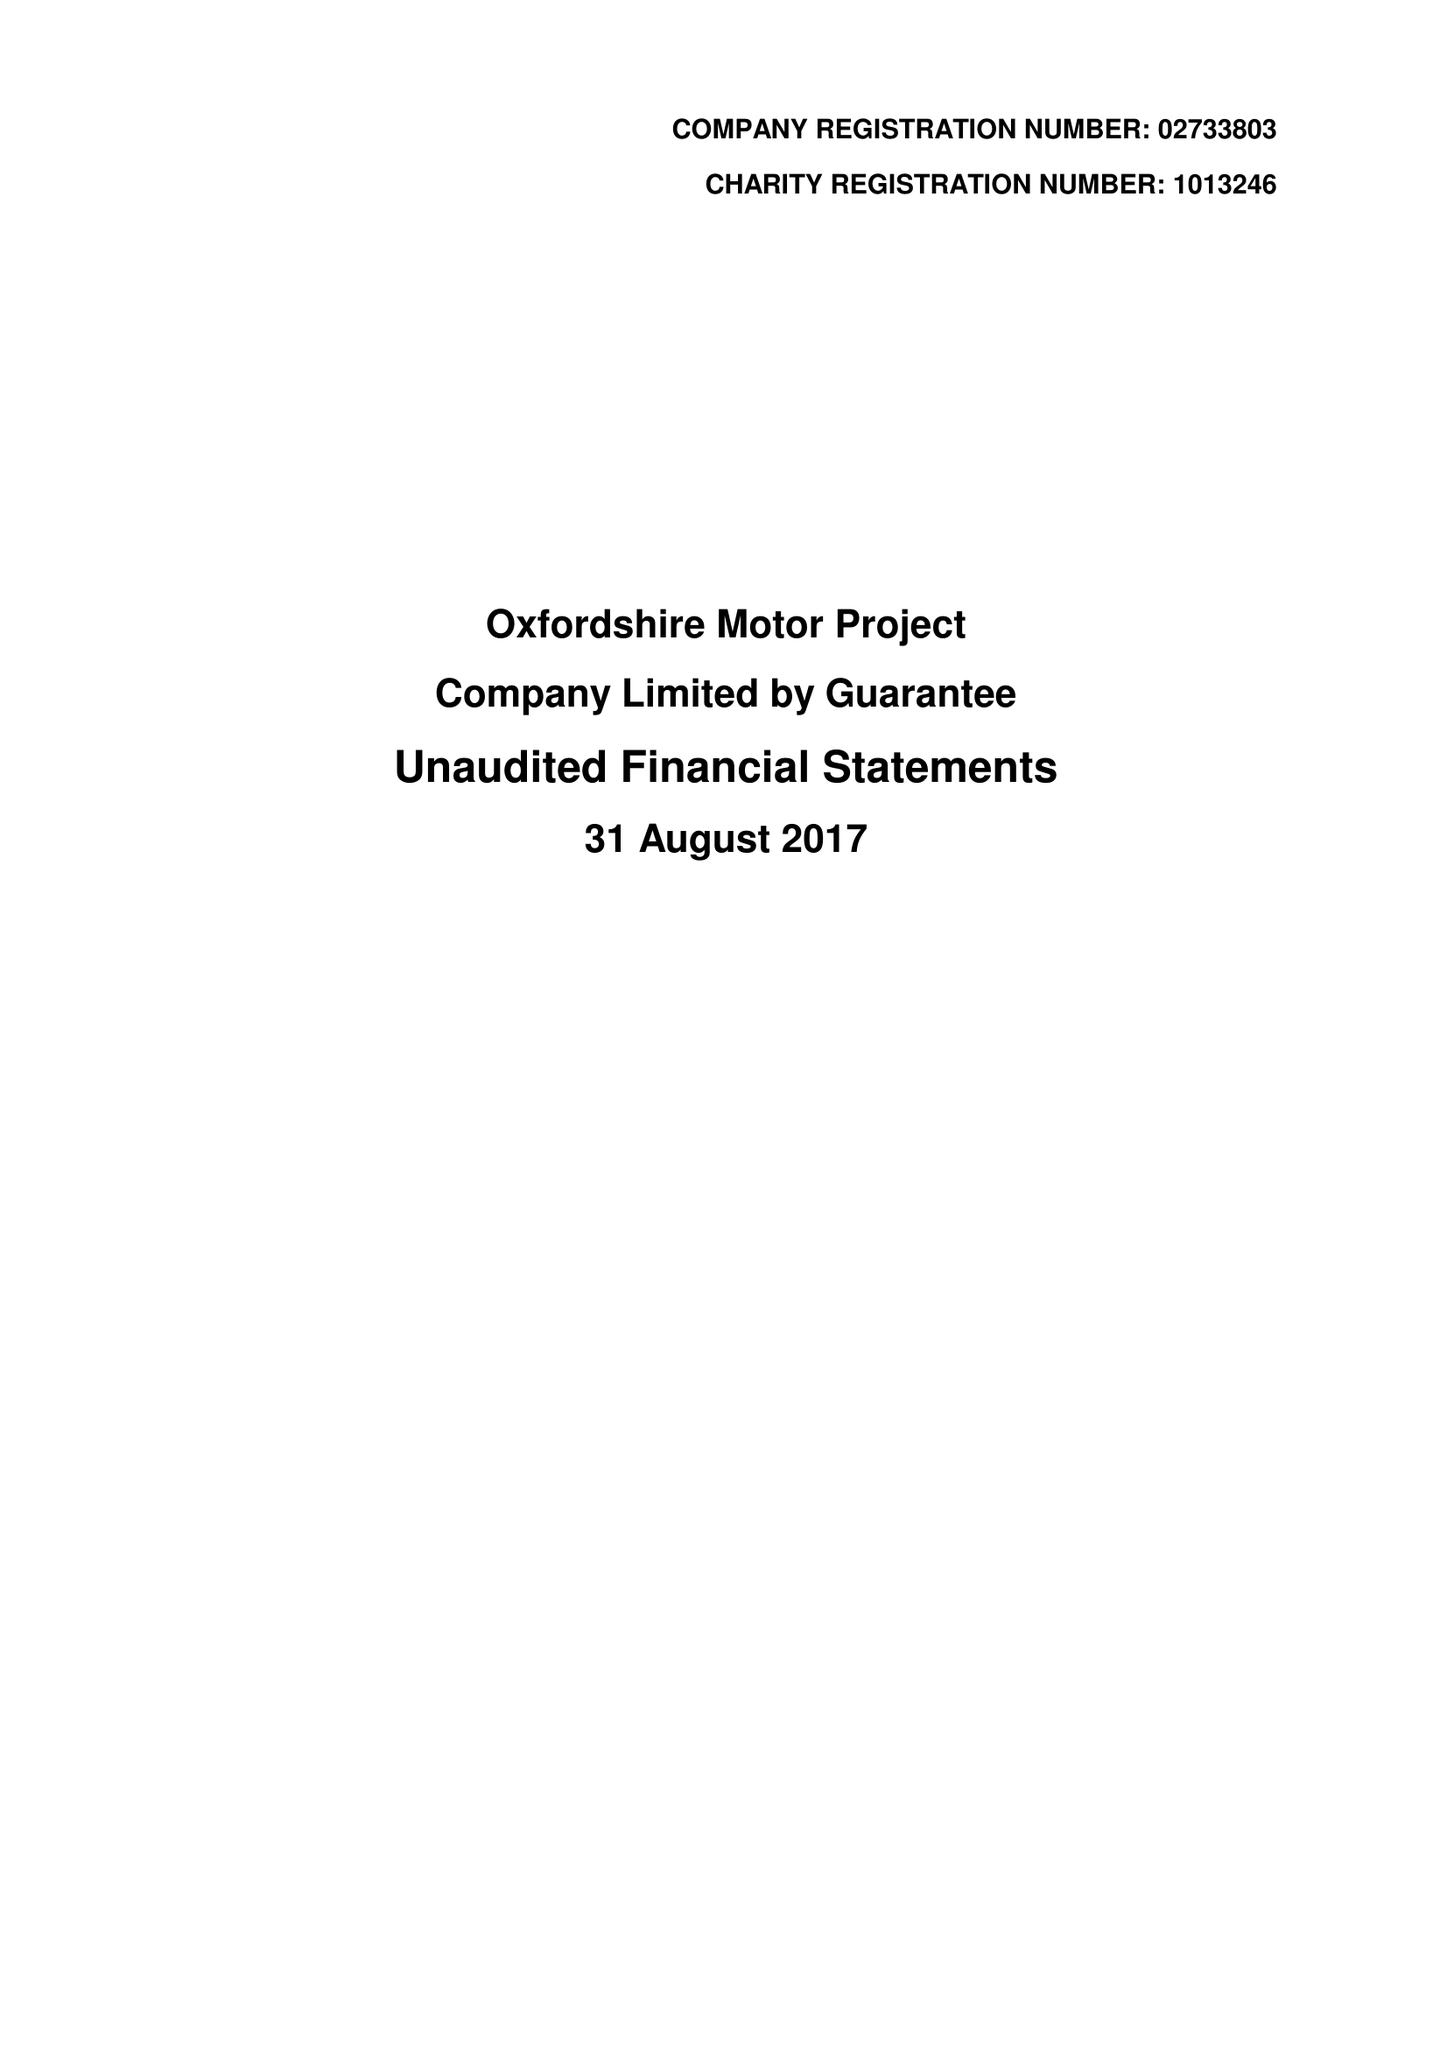What is the value for the charity_name?
Answer the question using a single word or phrase. Oxfordshire Motor Project 